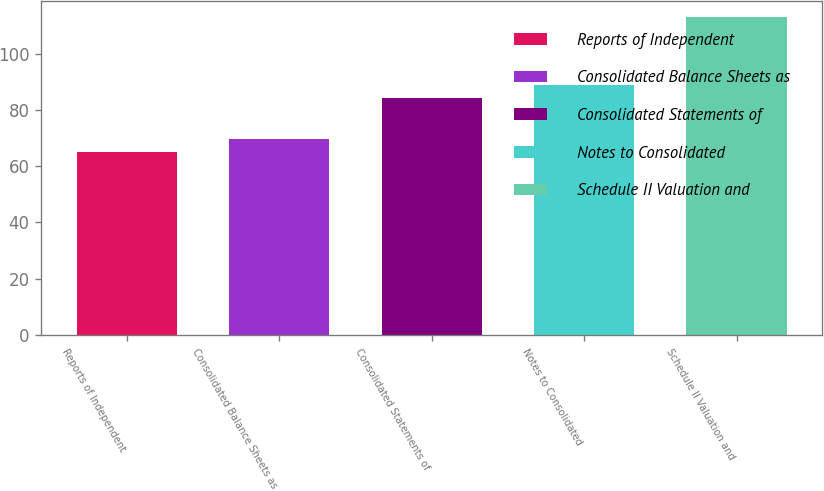<chart> <loc_0><loc_0><loc_500><loc_500><bar_chart><fcel>Reports of Independent<fcel>Consolidated Balance Sheets as<fcel>Consolidated Statements of<fcel>Notes to Consolidated<fcel>Schedule II Valuation and<nl><fcel>65<fcel>69.8<fcel>84.2<fcel>89<fcel>113<nl></chart> 